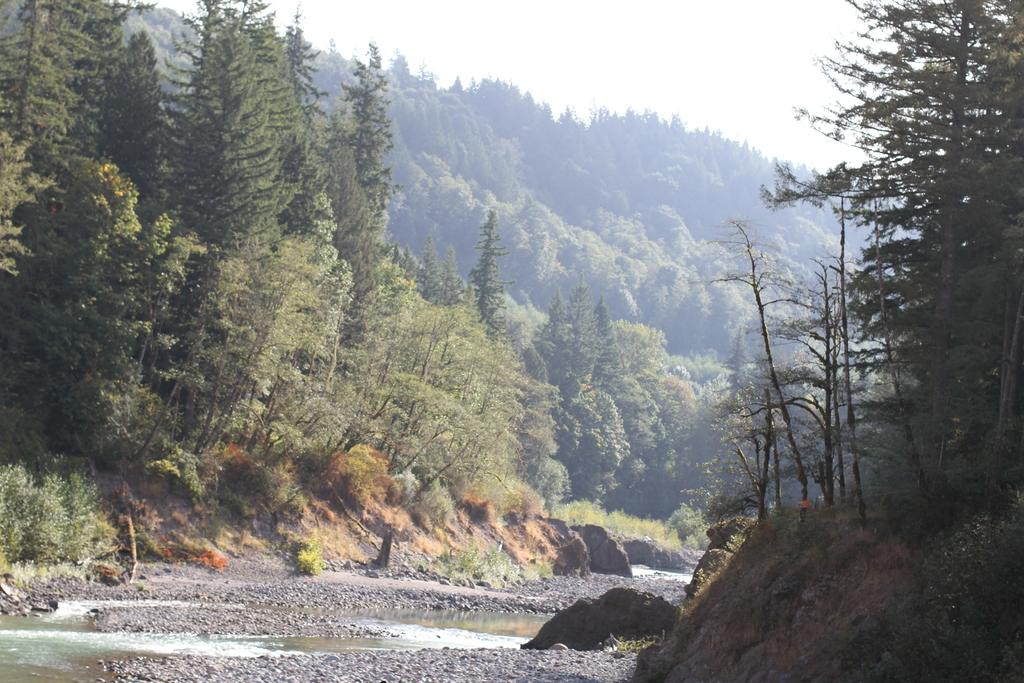What type of natural elements can be seen in the image? There are trees and water visible in the image. What other objects can be seen in the image? There are rocks in the image. What is visible in the background of the image? There are planets and the sky visible in the background of the image. What type of print can be seen on the bushes in the image? There are no bushes or prints visible in the image; it features trees, water, rocks, planets, and the sky. 